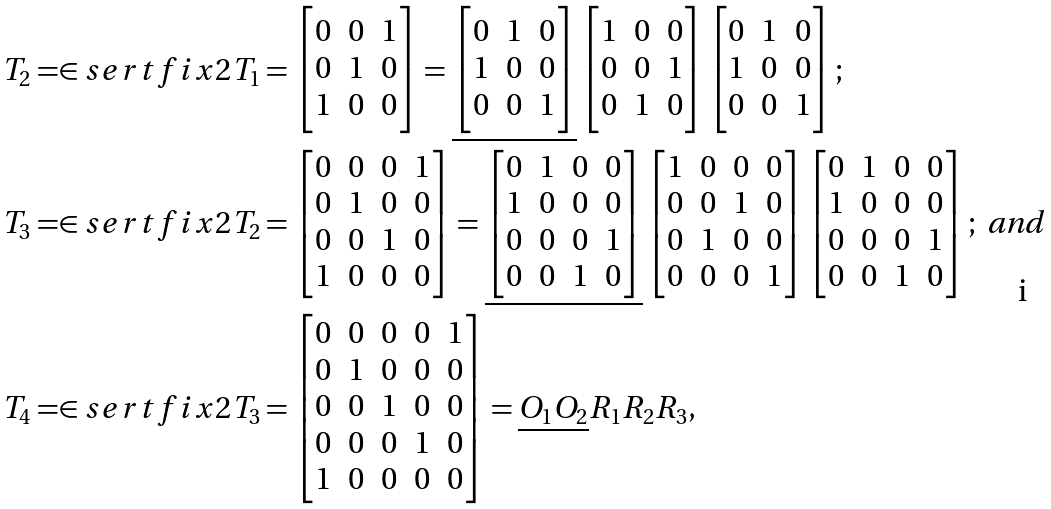<formula> <loc_0><loc_0><loc_500><loc_500>T _ { 2 } & = \in s e r t f i x { 2 } { T _ { 1 } } = \begin{bmatrix} 0 & 0 & 1 \\ 0 & 1 & 0 \\ 1 & 0 & 0 \end{bmatrix} = \underline { \begin{bmatrix} 0 & 1 & 0 \\ 1 & 0 & 0 \\ 0 & 0 & 1 \end{bmatrix} } \begin{bmatrix} 1 & 0 & 0 \\ 0 & 0 & 1 \\ 0 & 1 & 0 \end{bmatrix} \begin{bmatrix} 0 & 1 & 0 \\ 1 & 0 & 0 \\ 0 & 0 & 1 \end{bmatrix} ; \\ T _ { 3 } & = \in s e r t f i x { 2 } { T _ { 2 } } = \begin{bmatrix} 0 & 0 & 0 & 1 \\ 0 & 1 & 0 & 0 \\ 0 & 0 & 1 & 0 \\ 1 & 0 & 0 & 0 \end{bmatrix} = \underline { \begin{bmatrix} 0 & 1 & 0 & 0 \\ 1 & 0 & 0 & 0 \\ 0 & 0 & 0 & 1 \\ 0 & 0 & 1 & 0 \end{bmatrix} } \begin{bmatrix} 1 & 0 & 0 & 0 \\ 0 & 0 & 1 & 0 \\ 0 & 1 & 0 & 0 \\ 0 & 0 & 0 & 1 \end{bmatrix} \begin{bmatrix} 0 & 1 & 0 & 0 \\ 1 & 0 & 0 & 0 \\ 0 & 0 & 0 & 1 \\ 0 & 0 & 1 & 0 \end{bmatrix} ; \text { and } \\ T _ { 4 } & = \in s e r t f i x { 2 } { T _ { 3 } } = \begin{bmatrix} 0 & 0 & 0 & 0 & 1 \\ 0 & 1 & 0 & 0 & 0 \\ 0 & 0 & 1 & 0 & 0 \\ 0 & 0 & 0 & 1 & 0 \\ 1 & 0 & 0 & 0 & 0 \end{bmatrix} = \underline { O _ { 1 } O _ { 2 } } R _ { 1 } R _ { 2 } R _ { 3 } ,</formula> 